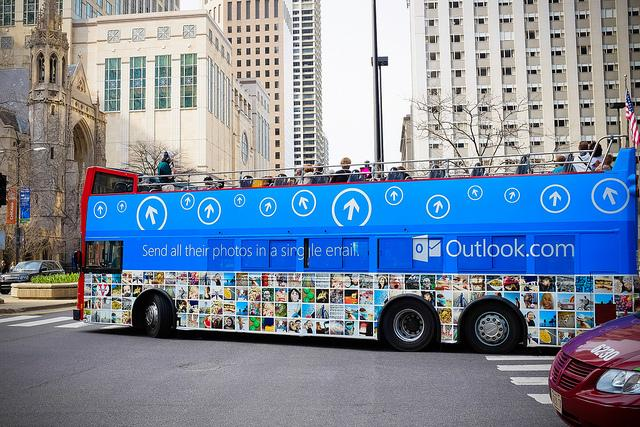What country is this street found in? Please explain your reasoning. united states. There is an american flag at the end of the bus. 